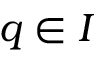Convert formula to latex. <formula><loc_0><loc_0><loc_500><loc_500>q \in I</formula> 